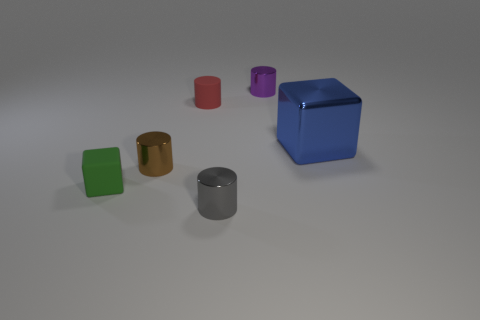Add 4 green matte things. How many objects exist? 10 Subtract all brown cylinders. How many cylinders are left? 3 Subtract all tiny gray metallic cylinders. How many cylinders are left? 3 Subtract all cylinders. How many objects are left? 2 Subtract 2 cylinders. How many cylinders are left? 2 Subtract all large blue objects. Subtract all blue shiny blocks. How many objects are left? 4 Add 1 tiny rubber things. How many tiny rubber things are left? 3 Add 2 small gray cylinders. How many small gray cylinders exist? 3 Subtract 1 gray cylinders. How many objects are left? 5 Subtract all cyan blocks. Subtract all purple spheres. How many blocks are left? 2 